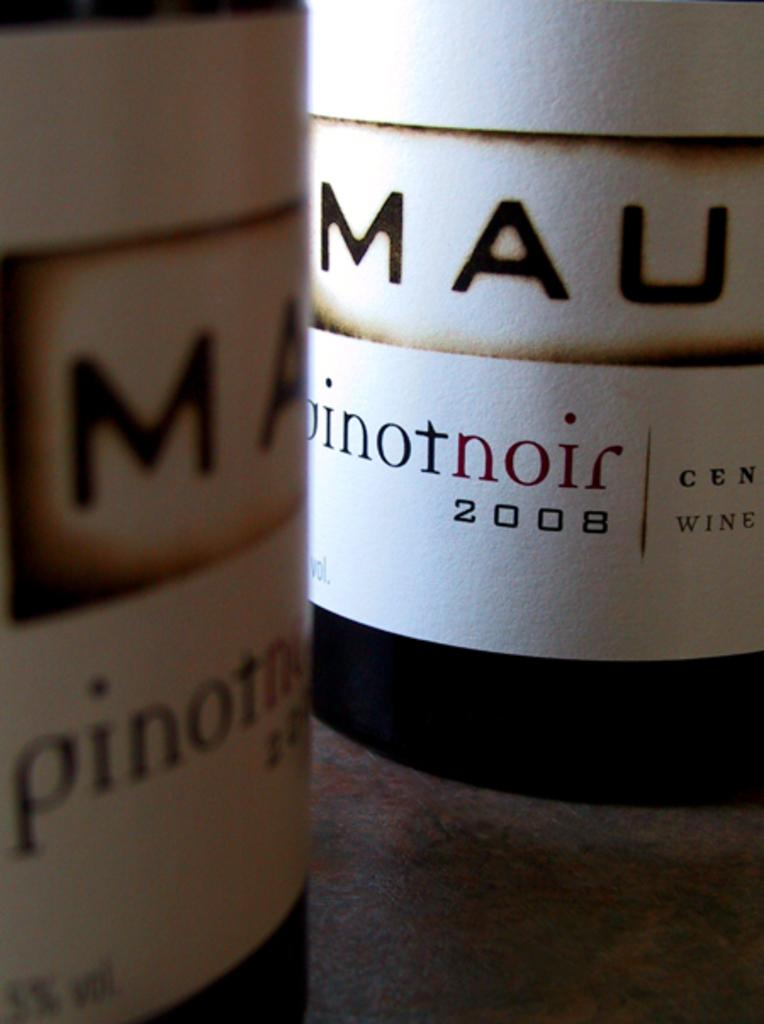<image>
Give a short and clear explanation of the subsequent image. Two bottles of Pinot Nor from 2008, it is very up close and personal. 